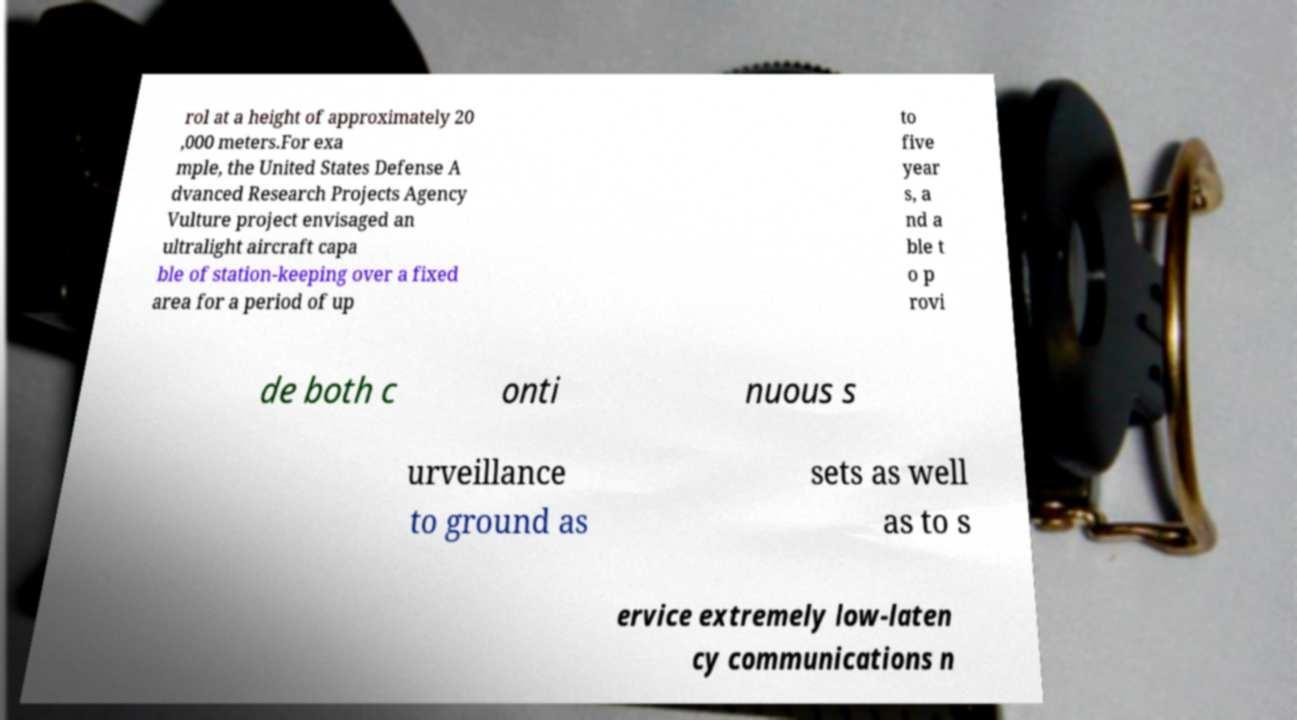Could you assist in decoding the text presented in this image and type it out clearly? rol at a height of approximately 20 ,000 meters.For exa mple, the United States Defense A dvanced Research Projects Agency Vulture project envisaged an ultralight aircraft capa ble of station-keeping over a fixed area for a period of up to five year s, a nd a ble t o p rovi de both c onti nuous s urveillance to ground as sets as well as to s ervice extremely low-laten cy communications n 